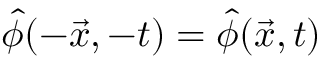<formula> <loc_0><loc_0><loc_500><loc_500>\hat { \phi } ( - \vec { x } , - t ) = \hat { \phi } ( \vec { x } , t )</formula> 